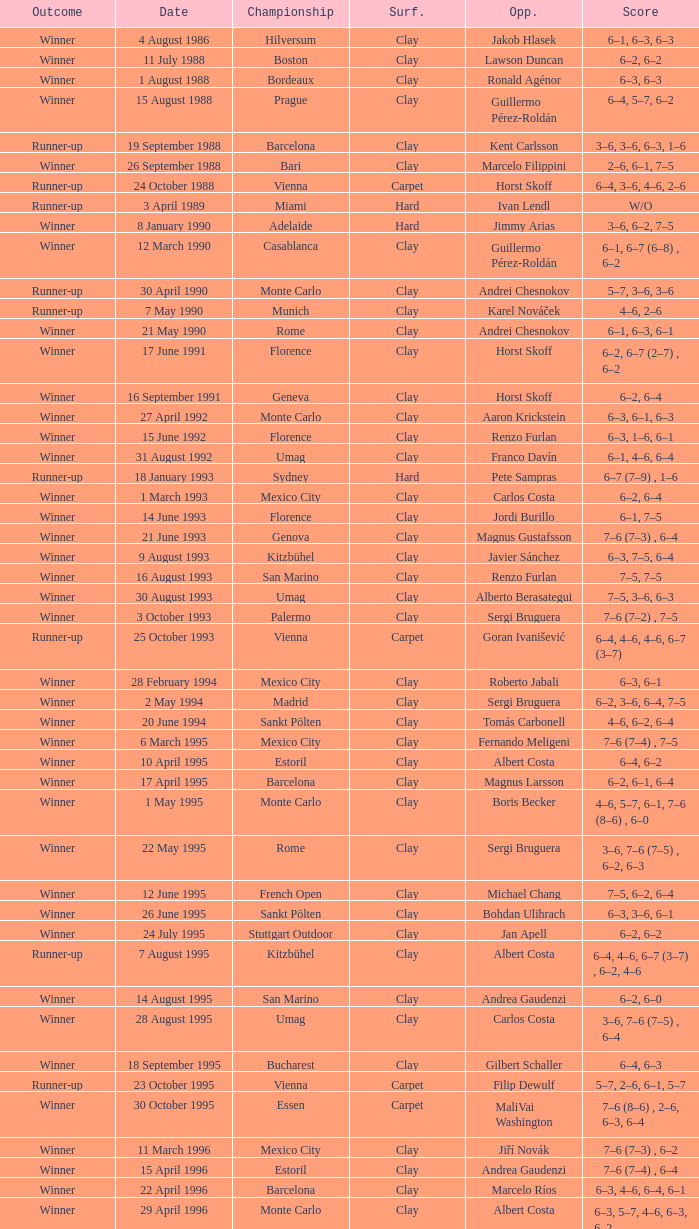What is the surface on 21 june 1993? Clay. 